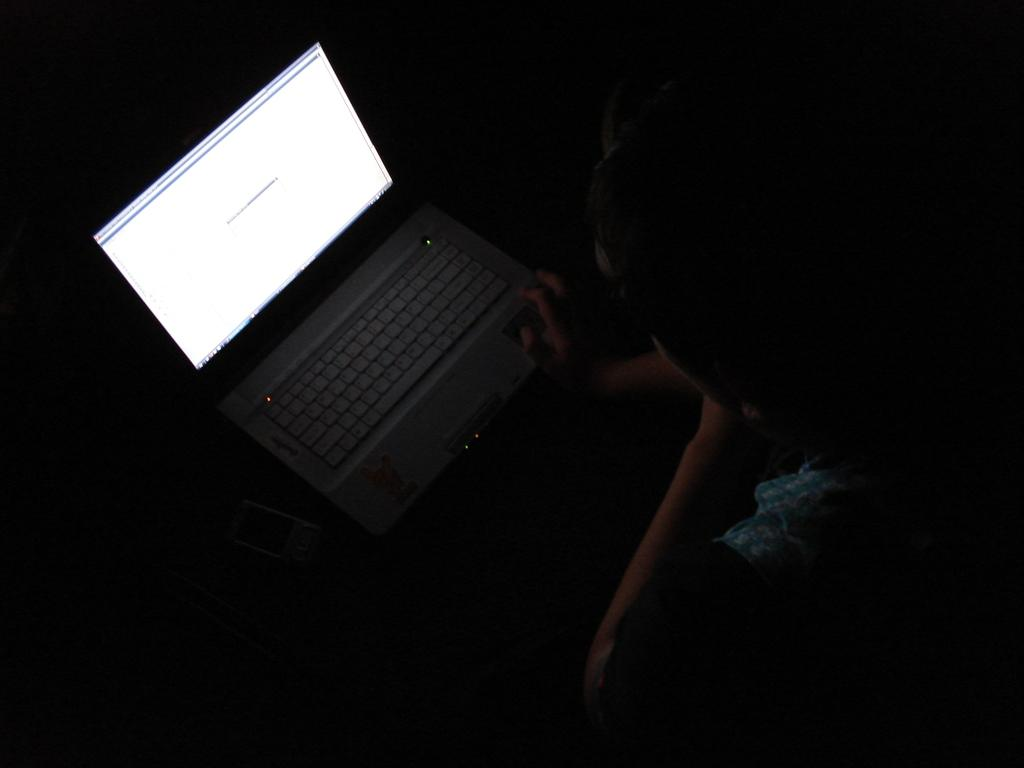What is the person in the image doing? The person is using a laptop. What can be inferred about the setting of the image based on the facts? The image is taken in a dark environment. What type of fog can be seen in the image? There is no fog present in the image; it is taken in a dark environment. What tools might the carpenter be using in the image? There is no carpenter present in the image, and therefore no tools can be observed. 